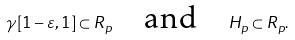Convert formula to latex. <formula><loc_0><loc_0><loc_500><loc_500>\gamma [ 1 - \varepsilon , 1 ] \subset R _ { p } \quad \text {and} \quad H _ { p } \subset R _ { p } .</formula> 